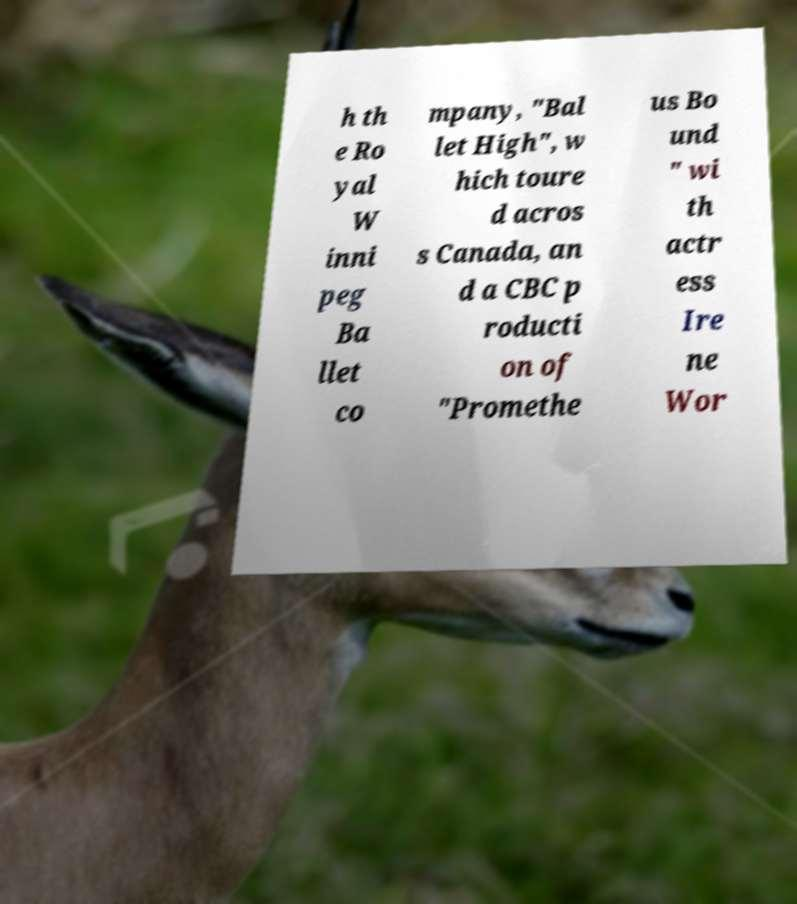Can you read and provide the text displayed in the image?This photo seems to have some interesting text. Can you extract and type it out for me? h th e Ro yal W inni peg Ba llet co mpany, "Bal let High", w hich toure d acros s Canada, an d a CBC p roducti on of "Promethe us Bo und " wi th actr ess Ire ne Wor 